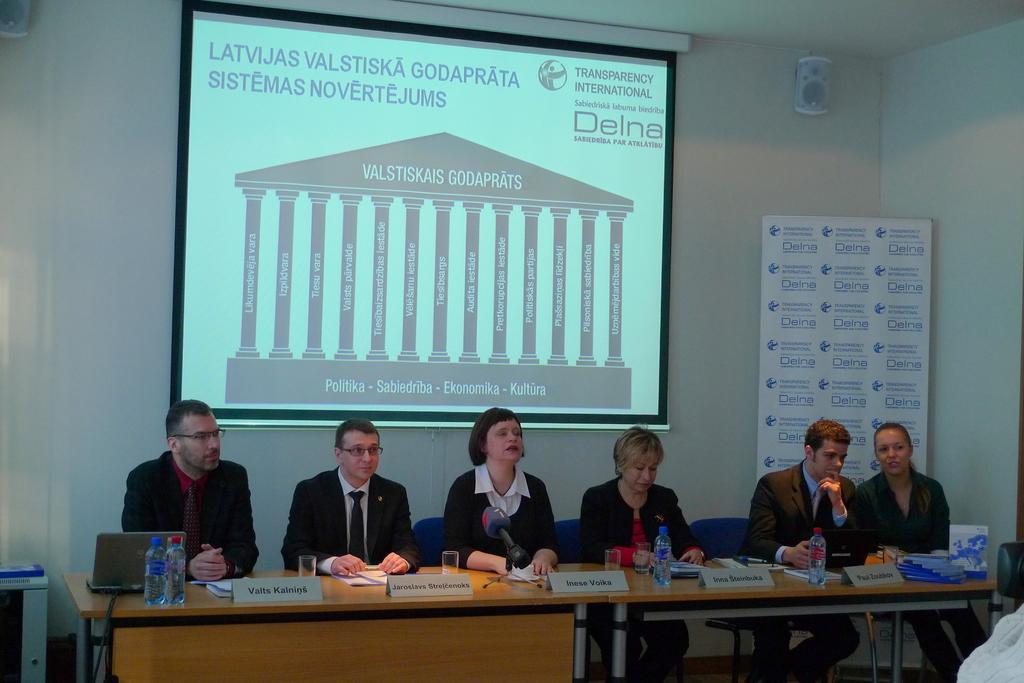Describe this image in one or two sentences. In this image we can see a group of people are sitting on the chairs, in front here is the table, laptop, and bottles and some objects on it, at back here is the projector screen, here is the wall. 